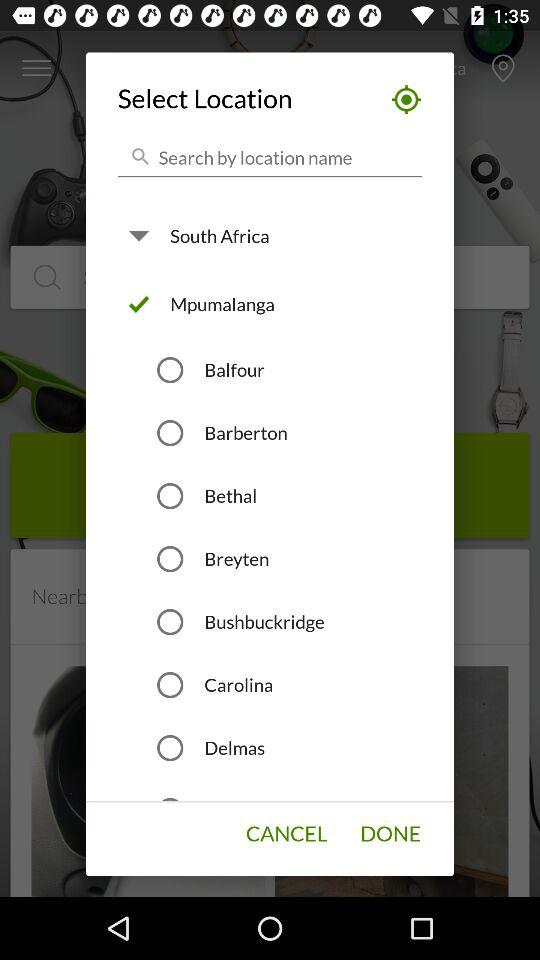Which town follows Delmas?
When the provided information is insufficient, respond with <no answer>. <no answer> 